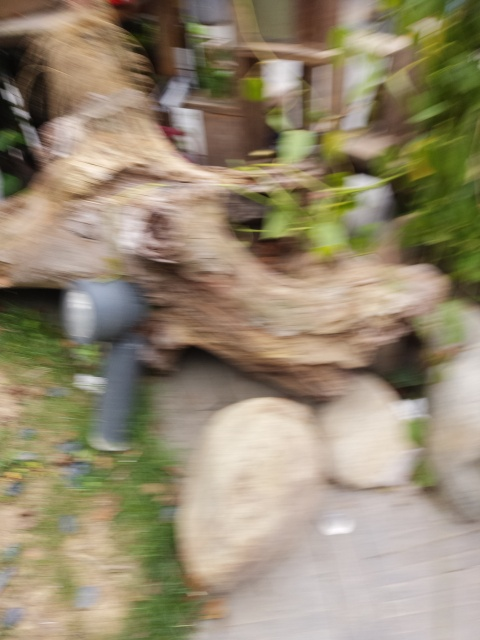Can you tell what might have caused the blur in this image? The blur in the image is likely due to camera movement while the photo was being taken. This could happen if the photographer's hand moved accidentally or if the camera shutter speed was too low to freeze motion when shooting handheld in a low-light situation. 